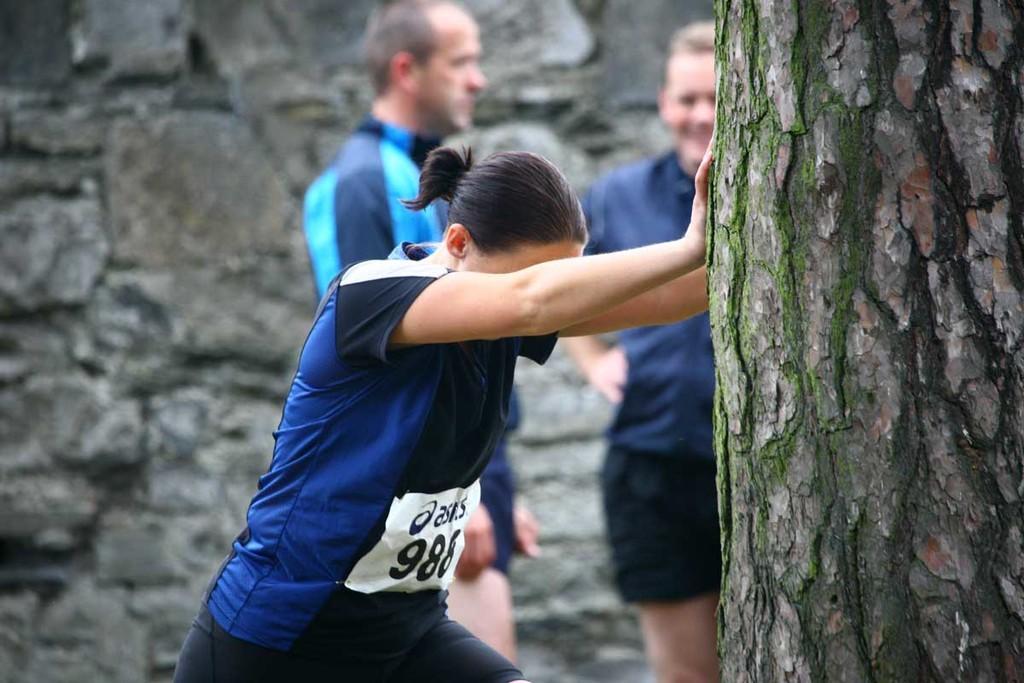Describe this image in one or two sentences. In this image I can see a person wearing blue, black and white colored dress and a tree trunk. I can see the blurry background in which I can see two persons standing and the rock wall. 